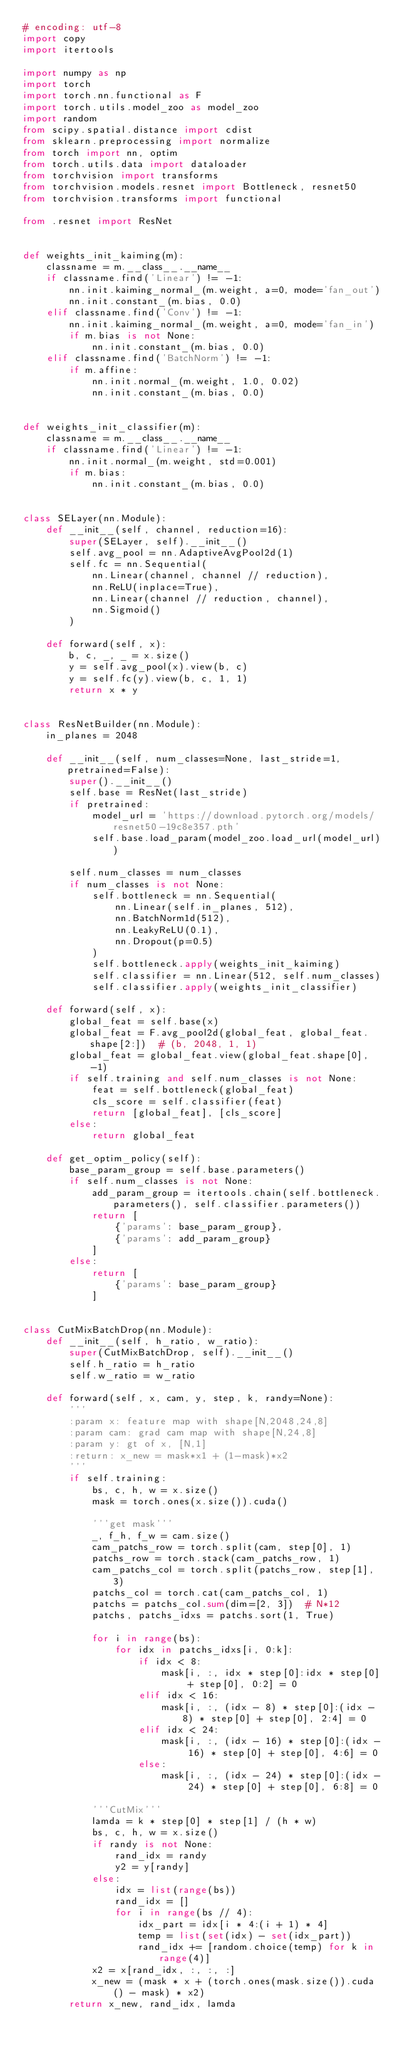Convert code to text. <code><loc_0><loc_0><loc_500><loc_500><_Python_># encoding: utf-8
import copy
import itertools

import numpy as np
import torch
import torch.nn.functional as F
import torch.utils.model_zoo as model_zoo
import random
from scipy.spatial.distance import cdist
from sklearn.preprocessing import normalize
from torch import nn, optim
from torch.utils.data import dataloader
from torchvision import transforms
from torchvision.models.resnet import Bottleneck, resnet50
from torchvision.transforms import functional

from .resnet import ResNet


def weights_init_kaiming(m):
    classname = m.__class__.__name__
    if classname.find('Linear') != -1:
        nn.init.kaiming_normal_(m.weight, a=0, mode='fan_out')
        nn.init.constant_(m.bias, 0.0)
    elif classname.find('Conv') != -1:
        nn.init.kaiming_normal_(m.weight, a=0, mode='fan_in')
        if m.bias is not None:
            nn.init.constant_(m.bias, 0.0)
    elif classname.find('BatchNorm') != -1:
        if m.affine:
            nn.init.normal_(m.weight, 1.0, 0.02)
            nn.init.constant_(m.bias, 0.0)


def weights_init_classifier(m):
    classname = m.__class__.__name__
    if classname.find('Linear') != -1:
        nn.init.normal_(m.weight, std=0.001)
        if m.bias:
            nn.init.constant_(m.bias, 0.0)


class SELayer(nn.Module):
    def __init__(self, channel, reduction=16):
        super(SELayer, self).__init__()
        self.avg_pool = nn.AdaptiveAvgPool2d(1)
        self.fc = nn.Sequential(
            nn.Linear(channel, channel // reduction),
            nn.ReLU(inplace=True),
            nn.Linear(channel // reduction, channel),
            nn.Sigmoid()
        )

    def forward(self, x):
        b, c, _, _ = x.size()
        y = self.avg_pool(x).view(b, c)
        y = self.fc(y).view(b, c, 1, 1)
        return x * y


class ResNetBuilder(nn.Module):
    in_planes = 2048

    def __init__(self, num_classes=None, last_stride=1, pretrained=False):
        super().__init__()
        self.base = ResNet(last_stride)
        if pretrained:
            model_url = 'https://download.pytorch.org/models/resnet50-19c8e357.pth'
            self.base.load_param(model_zoo.load_url(model_url))

        self.num_classes = num_classes
        if num_classes is not None:
            self.bottleneck = nn.Sequential(
                nn.Linear(self.in_planes, 512),
                nn.BatchNorm1d(512),
                nn.LeakyReLU(0.1),
                nn.Dropout(p=0.5)
            )
            self.bottleneck.apply(weights_init_kaiming)
            self.classifier = nn.Linear(512, self.num_classes)
            self.classifier.apply(weights_init_classifier)

    def forward(self, x):
        global_feat = self.base(x)
        global_feat = F.avg_pool2d(global_feat, global_feat.shape[2:])  # (b, 2048, 1, 1)
        global_feat = global_feat.view(global_feat.shape[0], -1)
        if self.training and self.num_classes is not None:
            feat = self.bottleneck(global_feat)
            cls_score = self.classifier(feat)
            return [global_feat], [cls_score]
        else:
            return global_feat

    def get_optim_policy(self):
        base_param_group = self.base.parameters()
        if self.num_classes is not None:
            add_param_group = itertools.chain(self.bottleneck.parameters(), self.classifier.parameters())
            return [
                {'params': base_param_group},
                {'params': add_param_group}
            ]
        else:
            return [
                {'params': base_param_group}
            ]


class CutMixBatchDrop(nn.Module):
    def __init__(self, h_ratio, w_ratio):
        super(CutMixBatchDrop, self).__init__()
        self.h_ratio = h_ratio
        self.w_ratio = w_ratio

    def forward(self, x, cam, y, step, k, randy=None):
        '''
        :param x: feature map with shape[N,2048,24,8]
        :param cam: grad cam map with shape[N,24,8]
        :param y: gt of x, [N,1]
        :return: x_new = mask*x1 + (1-mask)*x2
        '''
        if self.training:
            bs, c, h, w = x.size()
            mask = torch.ones(x.size()).cuda()

            '''get mask'''
            _, f_h, f_w = cam.size()
            cam_patchs_row = torch.split(cam, step[0], 1)
            patchs_row = torch.stack(cam_patchs_row, 1)
            cam_patchs_col = torch.split(patchs_row, step[1], 3)
            patchs_col = torch.cat(cam_patchs_col, 1)
            patchs = patchs_col.sum(dim=[2, 3])  # N*12
            patchs, patchs_idxs = patchs.sort(1, True)

            for i in range(bs):
                for idx in patchs_idxs[i, 0:k]:
                    if idx < 8:
                        mask[i, :, idx * step[0]:idx * step[0] + step[0], 0:2] = 0
                    elif idx < 16:
                        mask[i, :, (idx - 8) * step[0]:(idx - 8) * step[0] + step[0], 2:4] = 0
                    elif idx < 24:
                        mask[i, :, (idx - 16) * step[0]:(idx - 16) * step[0] + step[0], 4:6] = 0
                    else:
                        mask[i, :, (idx - 24) * step[0]:(idx - 24) * step[0] + step[0], 6:8] = 0

            '''CutMix'''
            lamda = k * step[0] * step[1] / (h * w)
            bs, c, h, w = x.size()
            if randy is not None:
                rand_idx = randy
                y2 = y[randy]
            else:
                idx = list(range(bs))
                rand_idx = []
                for i in range(bs // 4):
                    idx_part = idx[i * 4:(i + 1) * 4]
                    temp = list(set(idx) - set(idx_part))
                    rand_idx += [random.choice(temp) for k in range(4)]
            x2 = x[rand_idx, :, :, :]
            x_new = (mask * x + (torch.ones(mask.size()).cuda() - mask) * x2)
        return x_new, rand_idx, lamda

</code> 